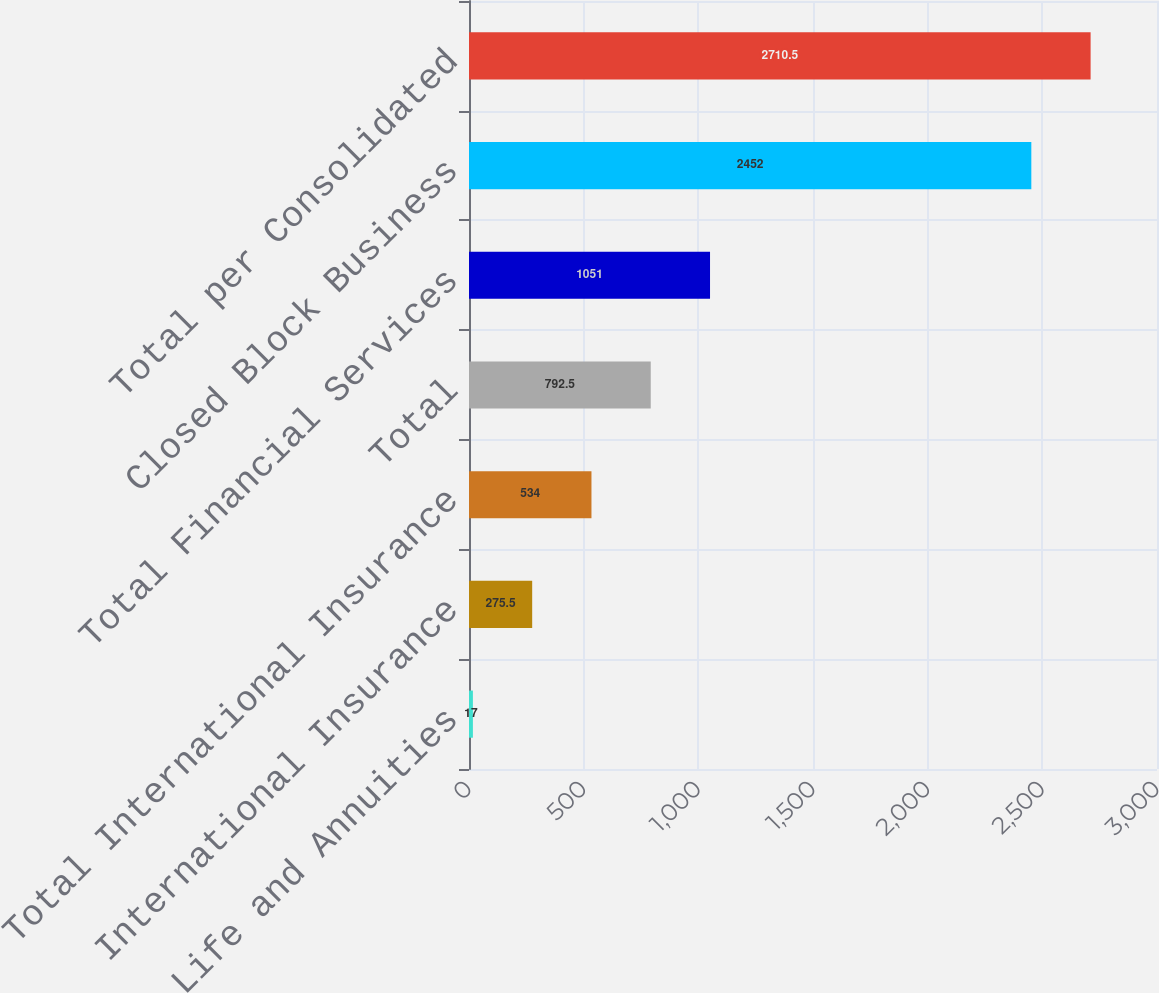<chart> <loc_0><loc_0><loc_500><loc_500><bar_chart><fcel>Individual Life and Annuities<fcel>International Insurance<fcel>Total International Insurance<fcel>Total<fcel>Total Financial Services<fcel>Closed Block Business<fcel>Total per Consolidated<nl><fcel>17<fcel>275.5<fcel>534<fcel>792.5<fcel>1051<fcel>2452<fcel>2710.5<nl></chart> 